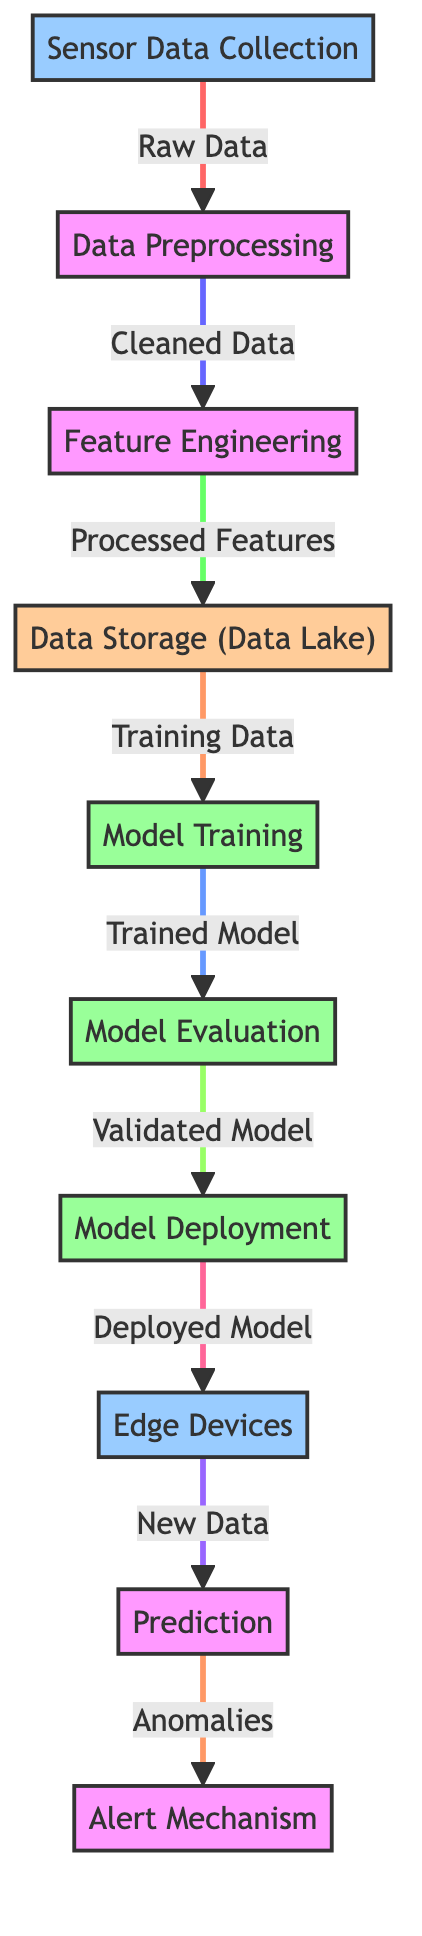What is the first step in the predictive maintenance model? The diagram shows that the first step is "Sensor Data Collection". This can be visually identified as the starting node in the flowchart, labeled at the top-left position.
Answer: Sensor Data Collection How many main processes are depicted in the diagram? By counting the nodes in the diagram, there are eight main processes outlined, including collection, preprocessing, feature engineering, storage, training, evaluation, deployment, prediction, and alert mechanism.
Answer: Eight What type of data is produced after the data preprocessing step? The arrow leading from "Data Preprocessing" to "Feature Engineering" specifies that "Cleaned Data" is produced, indicating the output of this step.
Answer: Cleaned Data Which component receives new data for prediction? The diagram indicates that "Edge Devices" is the component that receives new data to perform predictions, as shown in the flow leading to the "Prediction" node.
Answer: Edge Devices What is the output of the model training step? The diagram directly links "Model Training" to "Model Evaluation" with the annotation "Trained Model," indicating that the output of the training step is the trained model.
Answer: Trained Model Which two processes are directly linked to the alert mechanism? The flowchart shows that the "Prediction" process leads to the "Alert Mechanism," and the "prediction" node suggests a direct dependency on the prediction results indicating anomalies.
Answer: Prediction How many nodes are related to the model development process? The model development process includes three nodes: "Model Training", "Model Evaluation", and "Model Deployment". Counting these nodes gives a total of three related nodes.
Answer: Three What type of data is stored in the data lake? The diagram shows that after "Feature Engineering", the processed features are sent to "Data Storage (Data Lake)", indicating that processed features are the data type stored there.
Answer: Processed Features What alerting action occurs based on predictions? The last flow in the diagram indicates that the alert mechanism is triggered by "Anomalies" derived from the prediction step indicating intervention based on those anomalies.
Answer: Anomalies 